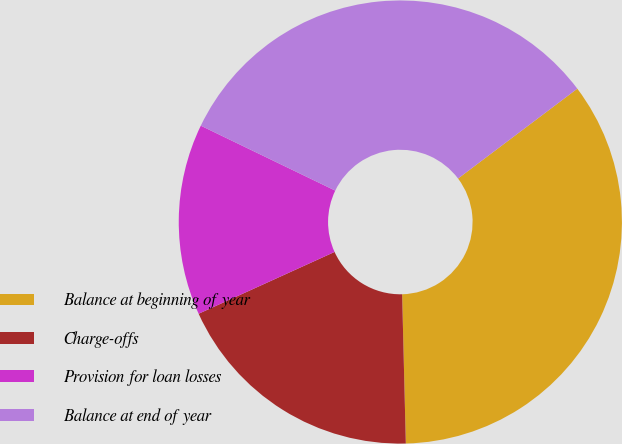<chart> <loc_0><loc_0><loc_500><loc_500><pie_chart><fcel>Balance at beginning of year<fcel>Charge-offs<fcel>Provision for loan losses<fcel>Balance at end of year<nl><fcel>34.88%<fcel>18.6%<fcel>13.95%<fcel>32.56%<nl></chart> 